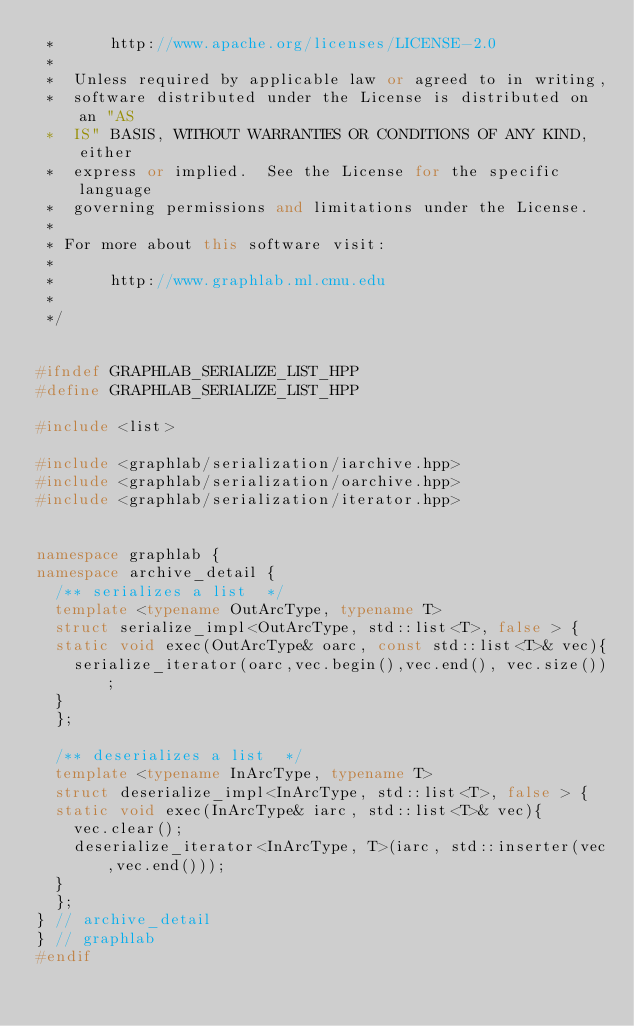<code> <loc_0><loc_0><loc_500><loc_500><_C++_> *      http://www.apache.org/licenses/LICENSE-2.0
 *
 *  Unless required by applicable law or agreed to in writing,
 *  software distributed under the License is distributed on an "AS
 *  IS" BASIS, WITHOUT WARRANTIES OR CONDITIONS OF ANY KIND, either
 *  express or implied.  See the License for the specific language
 *  governing permissions and limitations under the License.
 *
 * For more about this software visit:
 *
 *      http://www.graphlab.ml.cmu.edu
 *
 */


#ifndef GRAPHLAB_SERIALIZE_LIST_HPP
#define GRAPHLAB_SERIALIZE_LIST_HPP

#include <list>

#include <graphlab/serialization/iarchive.hpp>
#include <graphlab/serialization/oarchive.hpp>
#include <graphlab/serialization/iterator.hpp>


namespace graphlab {
namespace archive_detail {
  /** serializes a list  */
  template <typename OutArcType, typename T>
  struct serialize_impl<OutArcType, std::list<T>, false > {
  static void exec(OutArcType& oarc, const std::list<T>& vec){
    serialize_iterator(oarc,vec.begin(),vec.end(), vec.size());
  }
  };

  /** deserializes a list  */
  template <typename InArcType, typename T>
  struct deserialize_impl<InArcType, std::list<T>, false > {
  static void exec(InArcType& iarc, std::list<T>& vec){
    vec.clear();
    deserialize_iterator<InArcType, T>(iarc, std::inserter(vec,vec.end()));
  }
  };
} // archive_detail  
} // graphlab
#endif 

</code> 